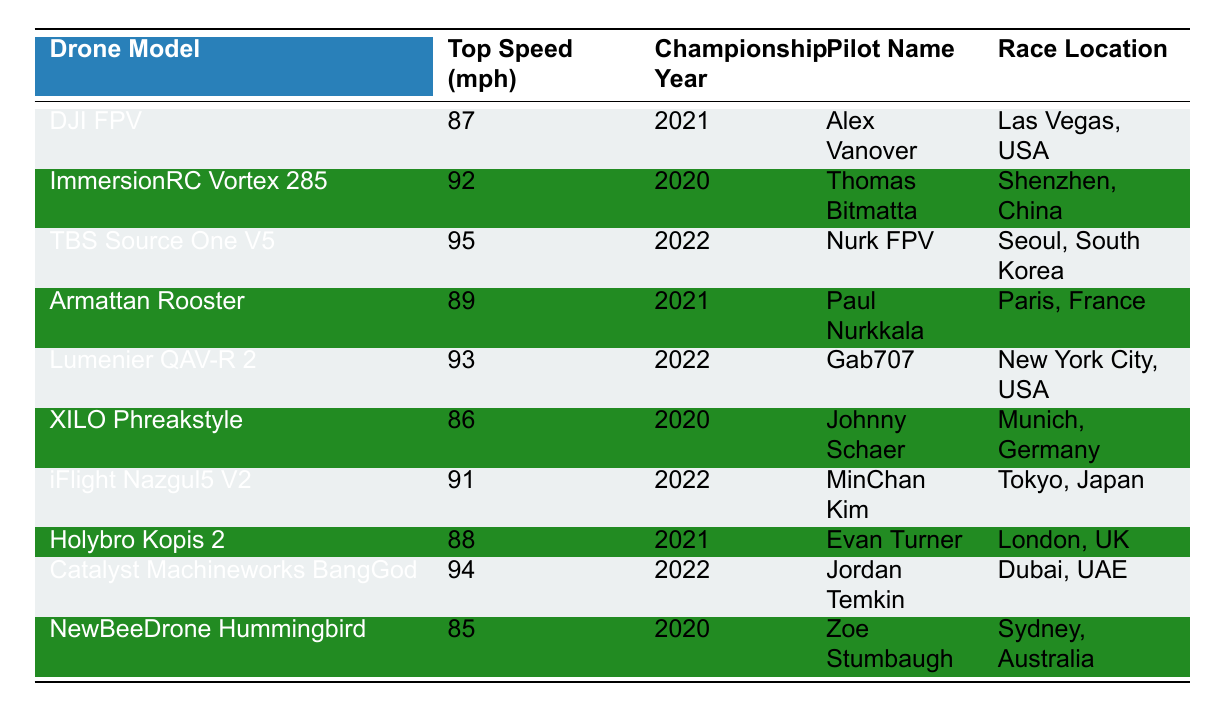What is the top speed achieved by the TBS Source One V5? In the table, the TBS Source One V5 has a top speed listed as 95 mph.
Answer: 95 mph Which drone model was piloted by Gab707? The table shows that Gab707 piloted the Lumenier QAV-R 2.
Answer: Lumenier QAV-R 2 Who achieved the highest top speed in the table? The TBS Source One V5 achieved the highest top speed of 95 mph among all listed drone models.
Answer: TBS Source One V5 True or False: The ImmersionRC Vortex 285 achieved a top speed of 92 mph in 2021. The table indicates that the ImmersionRC Vortex 285 achieved a top speed of 92 mph in 2020, not 2021. Therefore, this statement is false.
Answer: False What was the average top speed of all drones listed in the table? To find the average speed, first sum all top speeds: (87 + 92 + 95 + 89 + 93 + 86 + 91 + 88 + 94 + 85) = 909. There are 10 drone models, so the average is 909/10 = 90.9 mph.
Answer: 90.9 mph In which championship year did Alex Vanover participate, and what was his drone's top speed? According to the table, Alex Vanover participated in the 2021 championship year, and his drone (DJI FPV) had a top speed of 87 mph.
Answer: 2021, 87 mph Which pilot had the lowest top speed recorded in the table, and what was that speed? Upon examining the table, the lowest top speed belongs to the NewBeeDrone Hummingbird, piloted by Zoe Stumbaugh, which was 85 mph.
Answer: Zoe Stumbaugh, 85 mph How many pilots achieved top speeds over 90 mph in the championship races? The pilots with top speeds over 90 mph are: ImmersionRC Vortex 285 (92 mph), TBS Source One V5 (95 mph), Lumenier QAV-R 2 (93 mph), iFlight Nazgul5 V2 (91 mph), and Catalyst Machineworks BangGod (94 mph). That's a total of 5 pilots.
Answer: 5 pilots Which locations hosted the races for the drones with the highest speeds? The drones with the highest speeds are TBS Source One V5 (95 mph in Seoul, South Korea), and Catalyst Machineworks BangGod (94 mph in Dubai, UAE).
Answer: Seoul, South Korea; Dubai, UAE What is the difference in top speed between the fastest and slowest drone models listed? The fastest drone, TBS Source One V5, has a top speed of 95 mph, and the slowest, NewBeeDrone Hummingbird, has 85 mph. The difference is 95 - 85 = 10 mph.
Answer: 10 mph In which countries did the pilots who achieved top speeds of 92 mph or higher race? The pilots who achieved 92 mph or higher are: Thomas Bitmatta (Shenzhen, China), Nurk FPV (Seoul, South Korea), Gab707 (New York City, USA), MinChan Kim (Tokyo, Japan), Jordan Temkin (Dubai, UAE). The countries are China, South Korea, USA, Japan, and UAE.
Answer: China, South Korea, USA, Japan, UAE 